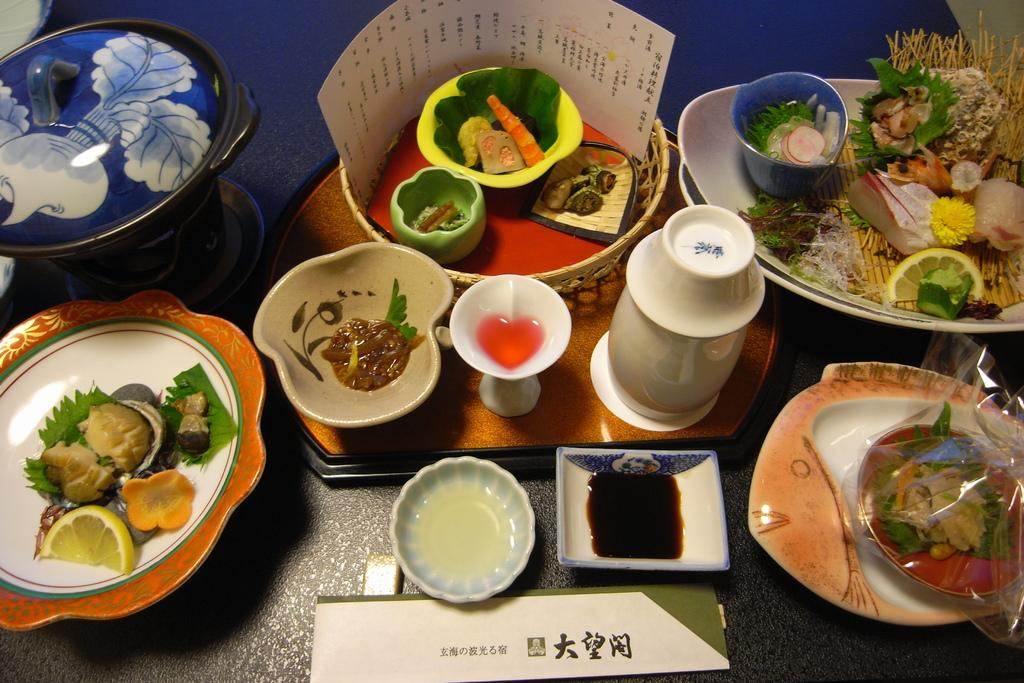What type of furniture is present in the image? There is a table in the image. What objects are placed on the table? There are plates, bowls, vessels, jars, paper, and a board on the table. What type of food can be seen on the table? There is food on the table. What accompaniments are visible in the image? There are sauces in the image. Can you see any wings on the table in the image? There are no wings present on the table in the image. What type of scale is used to weigh the food on the table? There is no scale visible in the image; it only shows the table with various objects and food. 